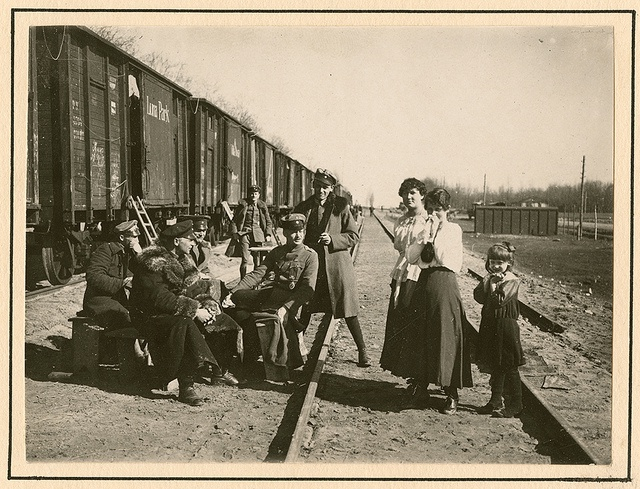Describe the objects in this image and their specific colors. I can see train in beige, black, gray, and darkgreen tones, people in beige, black, darkgreen, and gray tones, people in beige, black, gray, and darkgreen tones, people in beige, black, darkgray, and gray tones, and people in beige, black, gray, darkgray, and darkgreen tones in this image. 